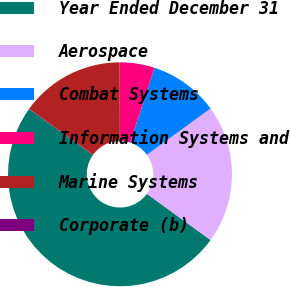<chart> <loc_0><loc_0><loc_500><loc_500><pie_chart><fcel>Year Ended December 31<fcel>Aerospace<fcel>Combat Systems<fcel>Information Systems and<fcel>Marine Systems<fcel>Corporate (b)<nl><fcel>49.9%<fcel>19.99%<fcel>10.02%<fcel>5.03%<fcel>15.0%<fcel>0.05%<nl></chart> 